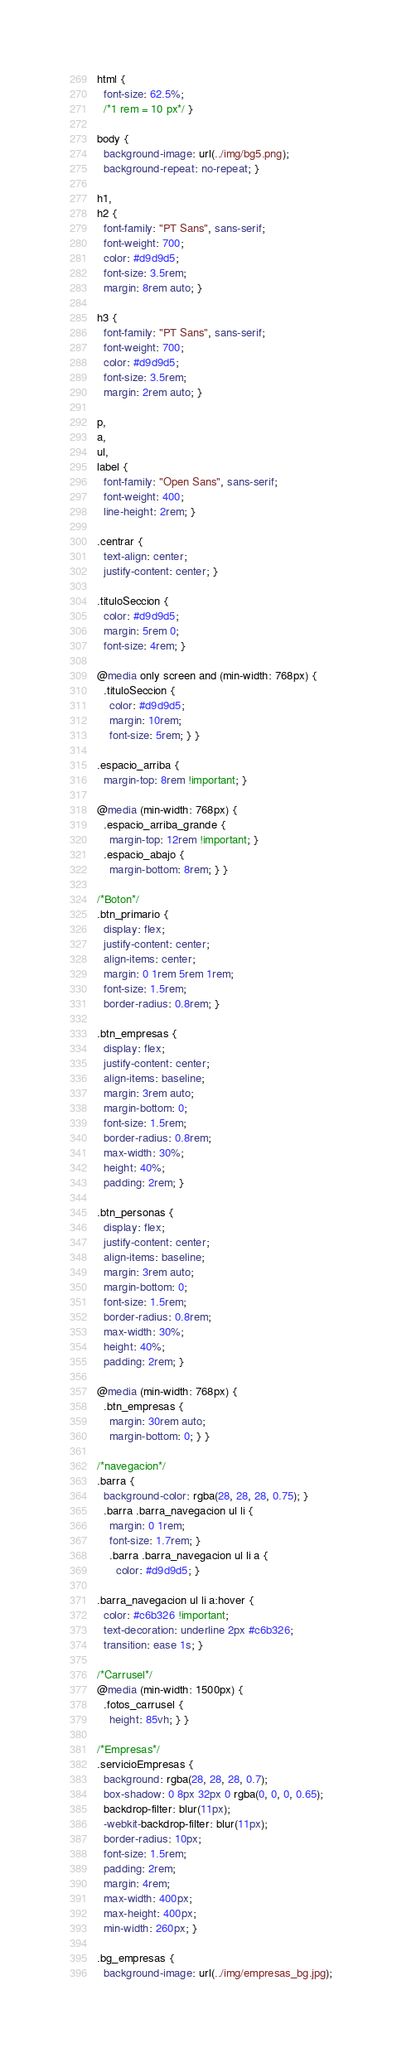<code> <loc_0><loc_0><loc_500><loc_500><_CSS_>html {
  font-size: 62.5%;
  /*1 rem = 10 px*/ }

body {
  background-image: url(../img/bg5.png);
  background-repeat: no-repeat; }

h1,
h2 {
  font-family: "PT Sans", sans-serif;
  font-weight: 700;
  color: #d9d9d5;
  font-size: 3.5rem;
  margin: 8rem auto; }

h3 {
  font-family: "PT Sans", sans-serif;
  font-weight: 700;
  color: #d9d9d5;
  font-size: 3.5rem;
  margin: 2rem auto; }

p,
a,
ul,
label {
  font-family: "Open Sans", sans-serif;
  font-weight: 400;
  line-height: 2rem; }

.centrar {
  text-align: center;
  justify-content: center; }

.tituloSeccion {
  color: #d9d9d5;
  margin: 5rem 0;
  font-size: 4rem; }

@media only screen and (min-width: 768px) {
  .tituloSeccion {
    color: #d9d9d5;
    margin: 10rem;
    font-size: 5rem; } }

.espacio_arriba {
  margin-top: 8rem !important; }

@media (min-width: 768px) {
  .espacio_arriba_grande {
    margin-top: 12rem !important; }
  .espacio_abajo {
    margin-bottom: 8rem; } }

/*Boton*/
.btn_primario {
  display: flex;
  justify-content: center;
  align-items: center;
  margin: 0 1rem 5rem 1rem;
  font-size: 1.5rem;
  border-radius: 0.8rem; }

.btn_empresas {
  display: flex;
  justify-content: center;
  align-items: baseline;
  margin: 3rem auto;
  margin-bottom: 0;
  font-size: 1.5rem;
  border-radius: 0.8rem;
  max-width: 30%;
  height: 40%;
  padding: 2rem; }

.btn_personas {
  display: flex;
  justify-content: center;
  align-items: baseline;
  margin: 3rem auto;
  margin-bottom: 0;
  font-size: 1.5rem;
  border-radius: 0.8rem;
  max-width: 30%;
  height: 40%;
  padding: 2rem; }

@media (min-width: 768px) {
  .btn_empresas {
    margin: 30rem auto;
    margin-bottom: 0; } }

/*navegacion*/
.barra {
  background-color: rgba(28, 28, 28, 0.75); }
  .barra .barra_navegacion ul li {
    margin: 0 1rem;
    font-size: 1.7rem; }
    .barra .barra_navegacion ul li a {
      color: #d9d9d5; }

.barra_navegacion ul li a:hover {
  color: #c6b326 !important;
  text-decoration: underline 2px #c6b326;
  transition: ease 1s; }

/*Carrusel*/
@media (min-width: 1500px) {
  .fotos_carrusel {
    height: 85vh; } }

/*Empresas*/
.servicioEmpresas {
  background: rgba(28, 28, 28, 0.7);
  box-shadow: 0 8px 32px 0 rgba(0, 0, 0, 0.65);
  backdrop-filter: blur(11px);
  -webkit-backdrop-filter: blur(11px);
  border-radius: 10px;
  font-size: 1.5rem;
  padding: 2rem;
  margin: 4rem;
  max-width: 400px;
  max-height: 400px;
  min-width: 260px; }

.bg_empresas {
  background-image: url(../img/empresas_bg.jpg);</code> 